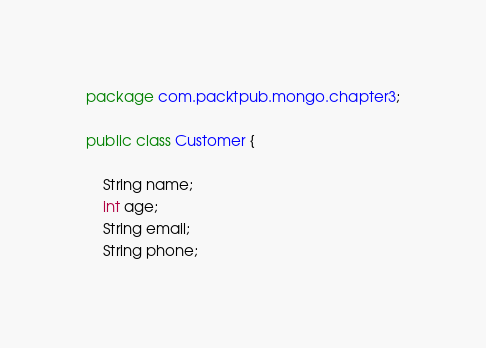<code> <loc_0><loc_0><loc_500><loc_500><_Java_>package com.packtpub.mongo.chapter3;

public class Customer {

	String name;
	int age;
	String email;
	String phone;
</code> 